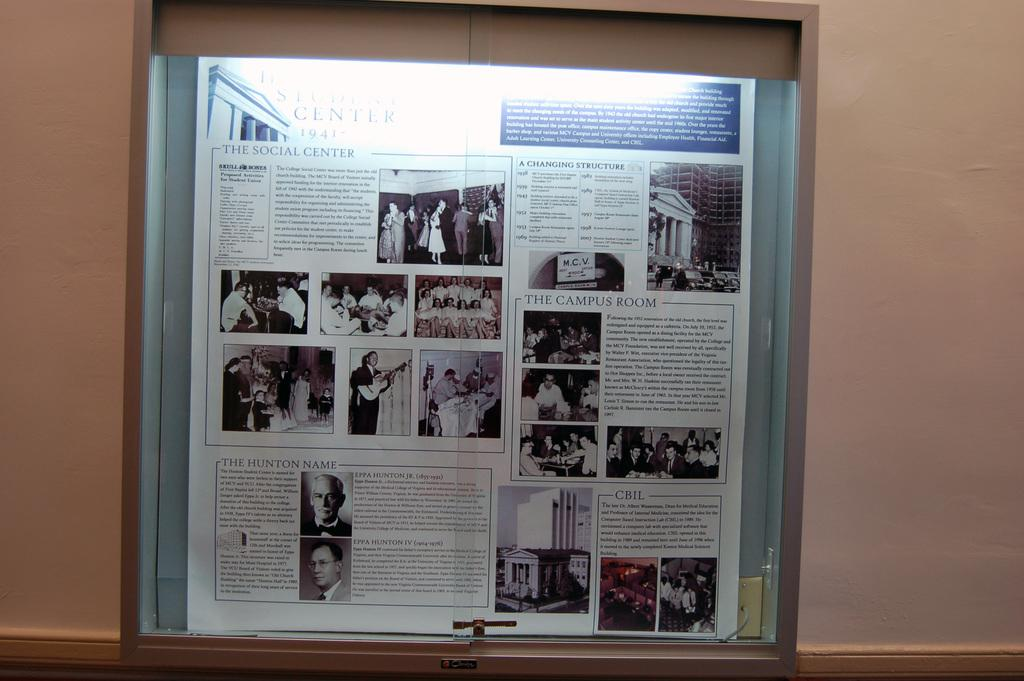What type of items are on the notice board in the image? There are paper clippings on the notice board in the image. Where is the notice board located? The notice board is on a wall. What type of fear does the creator of the paper clippings have? There is no information about the creator of the paper clippings or their fears in the image. 